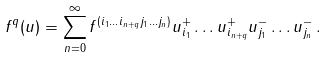<formula> <loc_0><loc_0><loc_500><loc_500>f ^ { q } ( u ) = \sum ^ { \infty } _ { n = 0 } f ^ { ( i _ { 1 } \dots i _ { n + q } j _ { 1 } \dots j _ { n } ) } u ^ { + } _ { i _ { 1 } } \dots u ^ { + } _ { i _ { n + q } } u ^ { - } _ { j _ { 1 } } \dots u ^ { - } _ { j _ { n } } \, .</formula> 